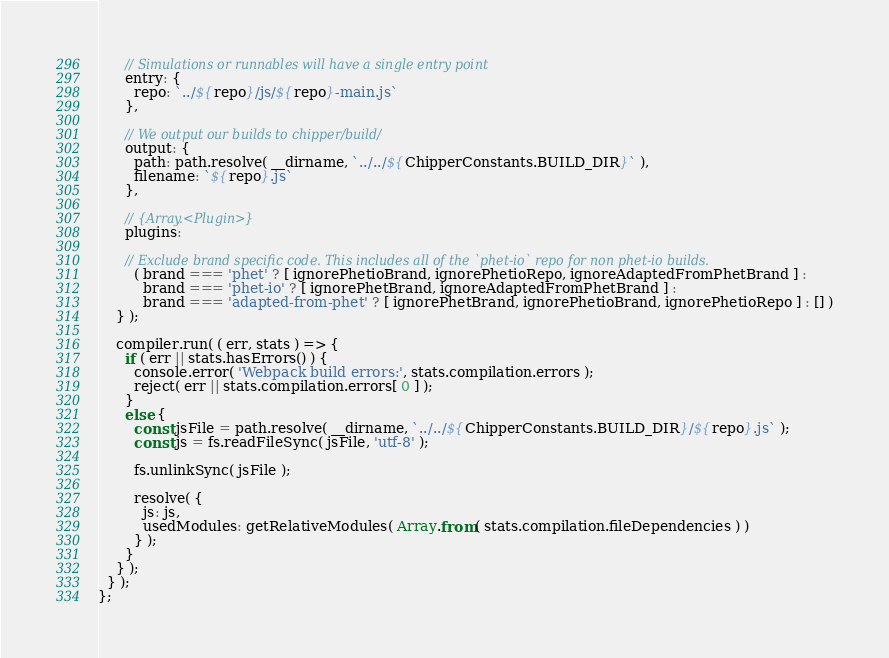<code> <loc_0><loc_0><loc_500><loc_500><_JavaScript_>
      // Simulations or runnables will have a single entry point
      entry: {
        repo: `../${repo}/js/${repo}-main.js`
      },

      // We output our builds to chipper/build/
      output: {
        path: path.resolve( __dirname, `../../${ChipperConstants.BUILD_DIR}` ),
        filename: `${repo}.js`
      },

      // {Array.<Plugin>}
      plugins:

      // Exclude brand specific code. This includes all of the `phet-io` repo for non phet-io builds.
        ( brand === 'phet' ? [ ignorePhetioBrand, ignorePhetioRepo, ignoreAdaptedFromPhetBrand ] :
          brand === 'phet-io' ? [ ignorePhetBrand, ignoreAdaptedFromPhetBrand ] :
          brand === 'adapted-from-phet' ? [ ignorePhetBrand, ignorePhetioBrand, ignorePhetioRepo ] : [] )
    } );

    compiler.run( ( err, stats ) => {
      if ( err || stats.hasErrors() ) {
        console.error( 'Webpack build errors:', stats.compilation.errors );
        reject( err || stats.compilation.errors[ 0 ] );
      }
      else {
        const jsFile = path.resolve( __dirname, `../../${ChipperConstants.BUILD_DIR}/${repo}.js` );
        const js = fs.readFileSync( jsFile, 'utf-8' );

        fs.unlinkSync( jsFile );

        resolve( {
          js: js,
          usedModules: getRelativeModules( Array.from( stats.compilation.fileDependencies ) )
        } );
      }
    } );
  } );
};
</code> 